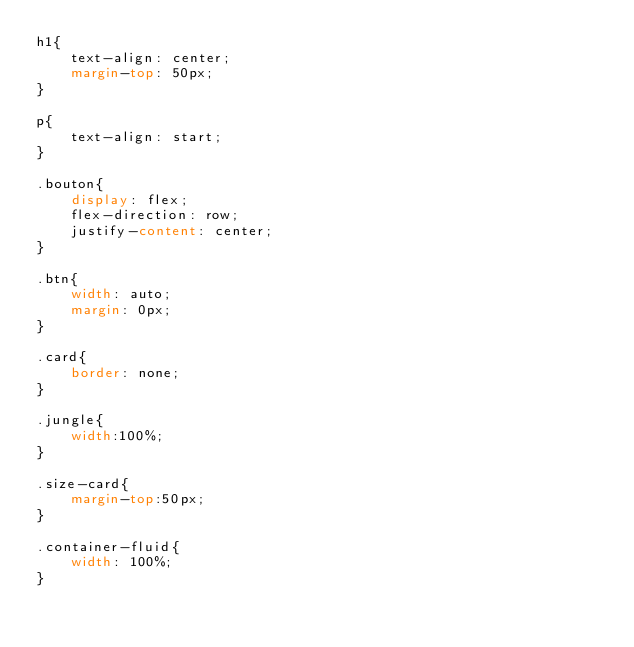Convert code to text. <code><loc_0><loc_0><loc_500><loc_500><_CSS_>h1{
    text-align: center;
    margin-top: 50px;
}

p{
    text-align: start;
}

.bouton{
    display: flex;
    flex-direction: row;
    justify-content: center;
}

.btn{
    width: auto;
    margin: 0px;
}

.card{
    border: none;
}

.jungle{
    width:100%;
}

.size-card{
    margin-top:50px;
}

.container-fluid{
    width: 100%;
}

</code> 